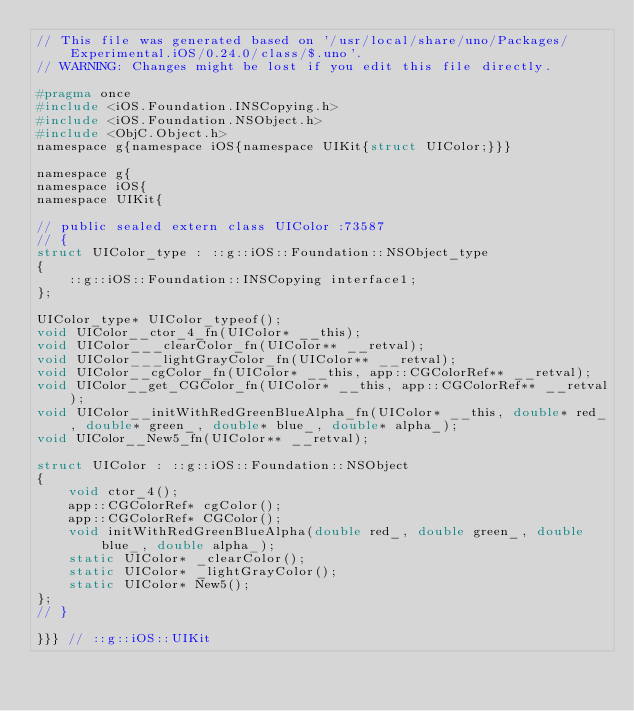Convert code to text. <code><loc_0><loc_0><loc_500><loc_500><_C_>// This file was generated based on '/usr/local/share/uno/Packages/Experimental.iOS/0.24.0/class/$.uno'.
// WARNING: Changes might be lost if you edit this file directly.

#pragma once
#include <iOS.Foundation.INSCopying.h>
#include <iOS.Foundation.NSObject.h>
#include <ObjC.Object.h>
namespace g{namespace iOS{namespace UIKit{struct UIColor;}}}

namespace g{
namespace iOS{
namespace UIKit{

// public sealed extern class UIColor :73587
// {
struct UIColor_type : ::g::iOS::Foundation::NSObject_type
{
    ::g::iOS::Foundation::INSCopying interface1;
};

UIColor_type* UIColor_typeof();
void UIColor__ctor_4_fn(UIColor* __this);
void UIColor___clearColor_fn(UIColor** __retval);
void UIColor___lightGrayColor_fn(UIColor** __retval);
void UIColor__cgColor_fn(UIColor* __this, app::CGColorRef** __retval);
void UIColor__get_CGColor_fn(UIColor* __this, app::CGColorRef** __retval);
void UIColor__initWithRedGreenBlueAlpha_fn(UIColor* __this, double* red_, double* green_, double* blue_, double* alpha_);
void UIColor__New5_fn(UIColor** __retval);

struct UIColor : ::g::iOS::Foundation::NSObject
{
    void ctor_4();
    app::CGColorRef* cgColor();
    app::CGColorRef* CGColor();
    void initWithRedGreenBlueAlpha(double red_, double green_, double blue_, double alpha_);
    static UIColor* _clearColor();
    static UIColor* _lightGrayColor();
    static UIColor* New5();
};
// }

}}} // ::g::iOS::UIKit
</code> 